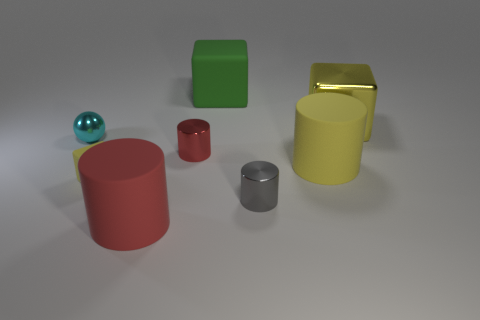There is another small block that is the same color as the metal cube; what is its material?
Offer a very short reply. Rubber. What number of matte objects are either cylinders or small yellow blocks?
Provide a short and direct response. 3. What is the shape of the large metallic thing?
Your response must be concise. Cube. How many tiny red cylinders are the same material as the green block?
Your answer should be compact. 0. What color is the other large cylinder that is made of the same material as the yellow cylinder?
Ensure brevity in your answer.  Red. Is the size of the yellow block that is in front of the cyan sphere the same as the gray cylinder?
Keep it short and to the point. Yes. There is another rubber object that is the same shape as the large red matte object; what color is it?
Keep it short and to the point. Yellow. The yellow matte object that is to the right of the rubber block behind the tiny cyan sphere that is in front of the yellow metal block is what shape?
Make the answer very short. Cylinder. Is the shape of the tiny gray thing the same as the red shiny object?
Provide a succinct answer. Yes. What is the shape of the big yellow object that is to the left of the yellow thing behind the cyan sphere?
Your answer should be very brief. Cylinder. 